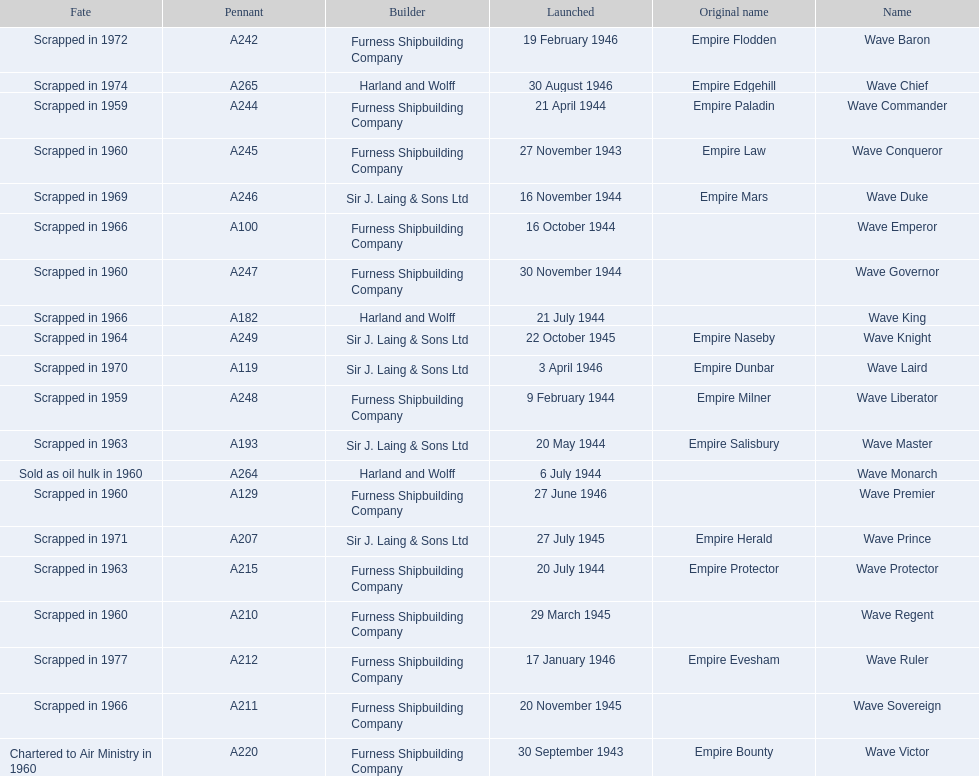What builders launched ships in november of any year? Furness Shipbuilding Company, Sir J. Laing & Sons Ltd, Furness Shipbuilding Company, Furness Shipbuilding Company. What ship builders ships had their original name's changed prior to scrapping? Furness Shipbuilding Company, Sir J. Laing & Sons Ltd. What was the name of the ship that was built in november and had its name changed prior to scrapping only 12 years after its launch? Wave Conqueror. 